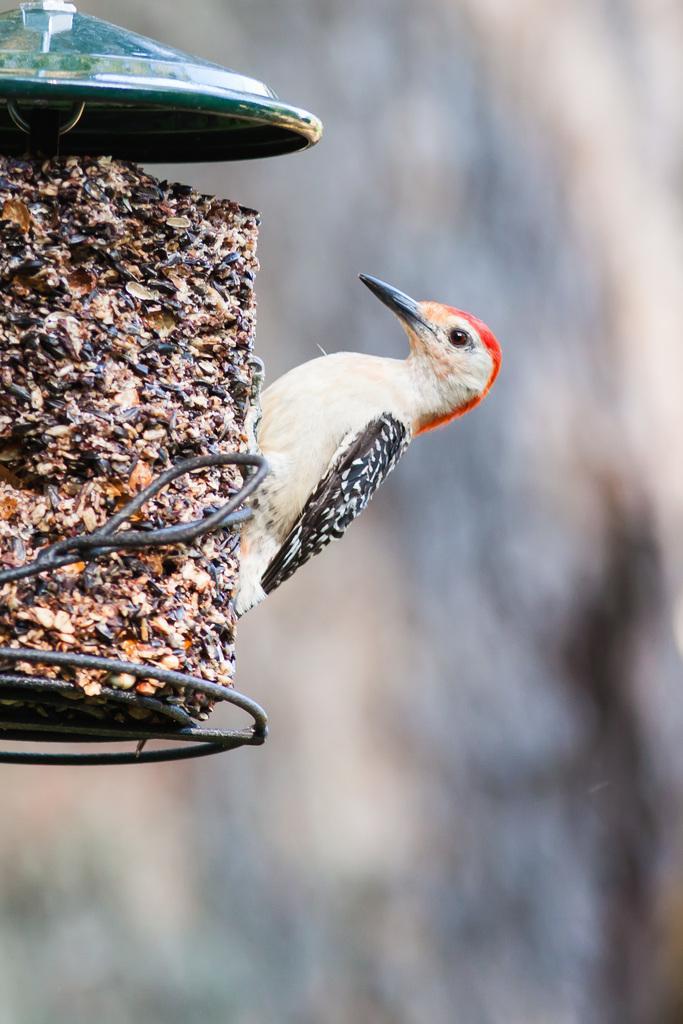In one or two sentences, can you explain what this image depicts? In this image we can see a bird on an object looks like a stand and a blurry background. 